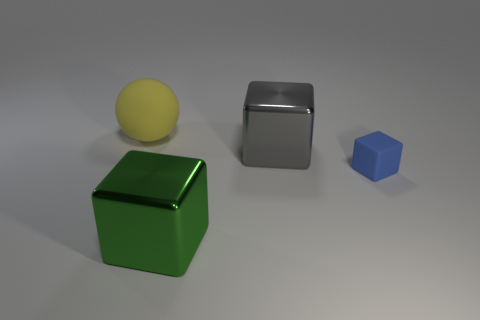How many cubes are either big yellow objects or rubber things?
Offer a terse response. 1. What is the color of the tiny matte object?
Your answer should be compact. Blue. Is the number of gray shiny blocks greater than the number of metallic cubes?
Your answer should be very brief. No. What number of things are either objects that are behind the large gray metallic object or big purple rubber things?
Provide a short and direct response. 1. Is the blue cube made of the same material as the ball?
Give a very brief answer. Yes. There is a gray shiny object that is the same shape as the green shiny object; what is its size?
Your response must be concise. Large. Does the object that is on the right side of the big gray thing have the same shape as the metal object in front of the big gray thing?
Your answer should be very brief. Yes. There is a green shiny block; does it have the same size as the matte thing right of the large matte thing?
Your answer should be compact. No. Is there any other thing that has the same shape as the large yellow rubber thing?
Your answer should be compact. No. What color is the matte thing right of the rubber thing to the left of the big object in front of the small blue matte thing?
Provide a short and direct response. Blue. 